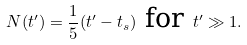<formula> <loc_0><loc_0><loc_500><loc_500>N ( t ^ { \prime } ) = \frac { 1 } { 5 } ( t ^ { \prime } - t _ { s } ) \text { for } t ^ { \prime } \gg 1 .</formula> 